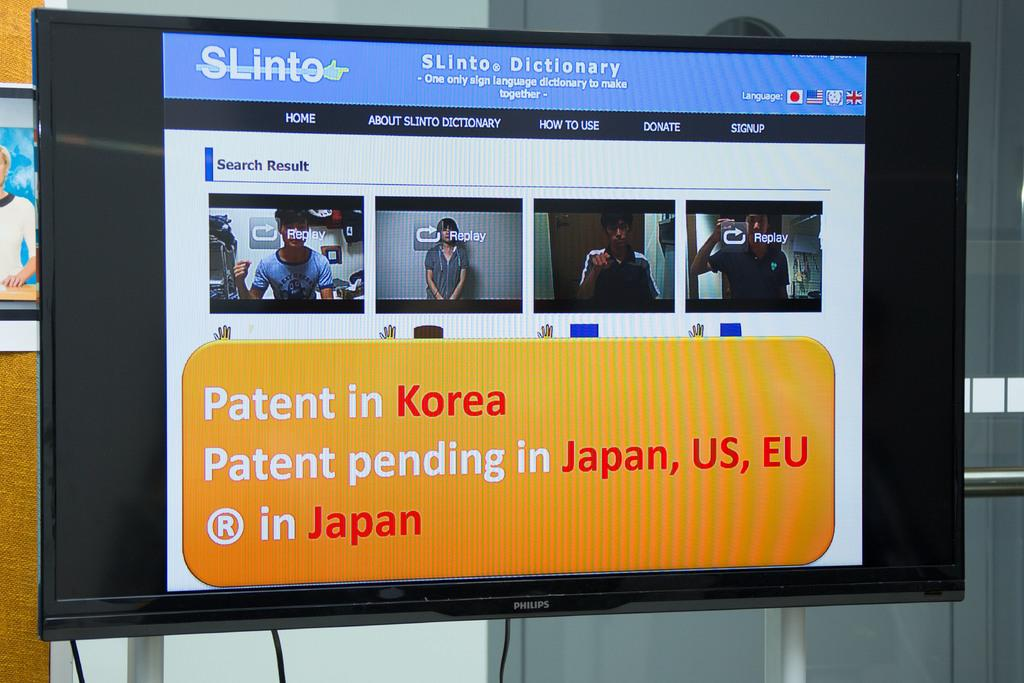<image>
Present a compact description of the photo's key features. a tv that says 'pantent in korea' on the screen of it 